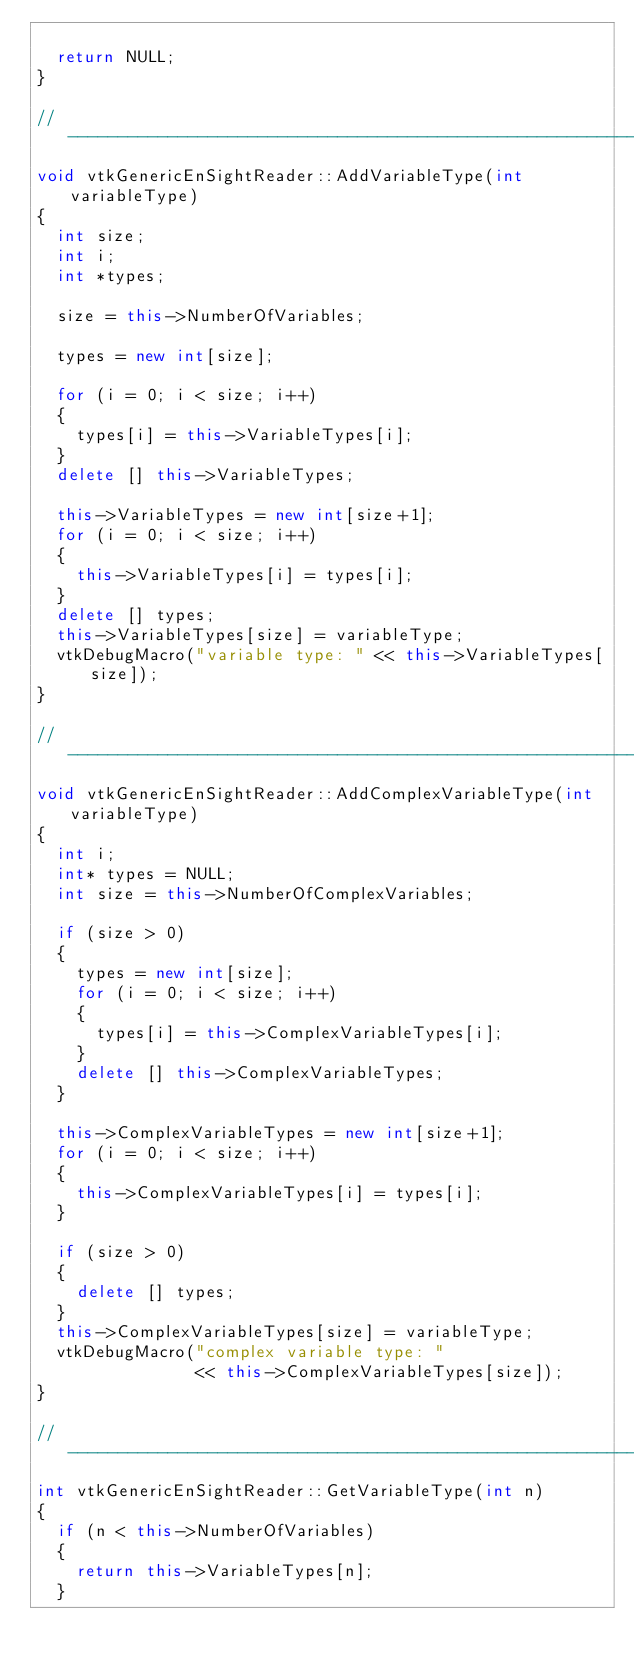<code> <loc_0><loc_0><loc_500><loc_500><_C++_>
  return NULL;
}

//----------------------------------------------------------------------------
void vtkGenericEnSightReader::AddVariableType(int variableType)
{
  int size;
  int i;
  int *types;

  size = this->NumberOfVariables;

  types = new int[size];

  for (i = 0; i < size; i++)
  {
    types[i] = this->VariableTypes[i];
  }
  delete [] this->VariableTypes;

  this->VariableTypes = new int[size+1];
  for (i = 0; i < size; i++)
  {
    this->VariableTypes[i] = types[i];
  }
  delete [] types;
  this->VariableTypes[size] = variableType;
  vtkDebugMacro("variable type: " << this->VariableTypes[size]);
}

//----------------------------------------------------------------------------
void vtkGenericEnSightReader::AddComplexVariableType(int variableType)
{
  int i;
  int* types = NULL;
  int size = this->NumberOfComplexVariables;

  if (size > 0)
  {
    types = new int[size];
    for (i = 0; i < size; i++)
    {
      types[i] = this->ComplexVariableTypes[i];
    }
    delete [] this->ComplexVariableTypes;
  }

  this->ComplexVariableTypes = new int[size+1];
  for (i = 0; i < size; i++)
  {
    this->ComplexVariableTypes[i] = types[i];
  }

  if (size > 0)
  {
    delete [] types;
  }
  this->ComplexVariableTypes[size] = variableType;
  vtkDebugMacro("complex variable type: "
                << this->ComplexVariableTypes[size]);
}

//----------------------------------------------------------------------------
int vtkGenericEnSightReader::GetVariableType(int n)
{
  if (n < this->NumberOfVariables)
  {
    return this->VariableTypes[n];
  }</code> 